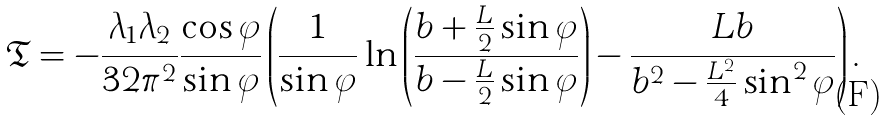Convert formula to latex. <formula><loc_0><loc_0><loc_500><loc_500>\mathfrak { T } = - \frac { \lambda _ { 1 } \lambda _ { 2 } } { 3 2 \pi ^ { 2 } } \frac { \cos \varphi } { \sin \varphi } \left ( \frac { 1 } { \sin \varphi } \ln \left ( \frac { b + \frac { L } { 2 } \sin \varphi } { b - \frac { L } { 2 } \sin \varphi } \right ) - \frac { L b } { b ^ { 2 } - \frac { L ^ { 2 } } { 4 } \sin ^ { 2 } \varphi } \right ) .</formula> 